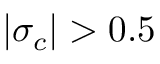Convert formula to latex. <formula><loc_0><loc_0><loc_500><loc_500>| \sigma _ { c } | > 0 . 5</formula> 